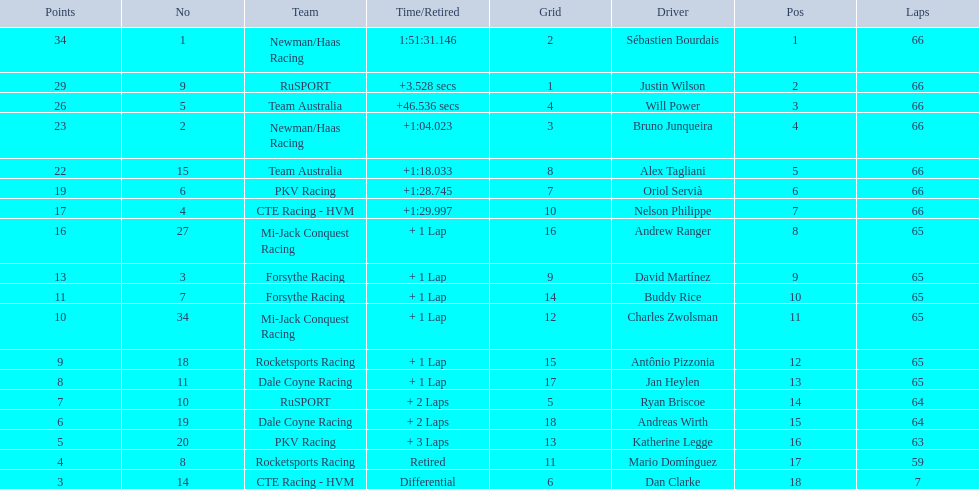Who are the drivers? Sébastien Bourdais, Justin Wilson, Will Power, Bruno Junqueira, Alex Tagliani, Oriol Servià, Nelson Philippe, Andrew Ranger, David Martínez, Buddy Rice, Charles Zwolsman, Antônio Pizzonia, Jan Heylen, Ryan Briscoe, Andreas Wirth, Katherine Legge, Mario Domínguez, Dan Clarke. What are their numbers? 1, 9, 5, 2, 15, 6, 4, 27, 3, 7, 34, 18, 11, 10, 19, 20, 8, 14. What are their positions? 1, 2, 3, 4, 5, 6, 7, 8, 9, 10, 11, 12, 13, 14, 15, 16, 17, 18. Parse the full table. {'header': ['Points', 'No', 'Team', 'Time/Retired', 'Grid', 'Driver', 'Pos', 'Laps'], 'rows': [['34', '1', 'Newman/Haas Racing', '1:51:31.146', '2', 'Sébastien Bourdais', '1', '66'], ['29', '9', 'RuSPORT', '+3.528 secs', '1', 'Justin Wilson', '2', '66'], ['26', '5', 'Team Australia', '+46.536 secs', '4', 'Will Power', '3', '66'], ['23', '2', 'Newman/Haas Racing', '+1:04.023', '3', 'Bruno Junqueira', '4', '66'], ['22', '15', 'Team Australia', '+1:18.033', '8', 'Alex Tagliani', '5', '66'], ['19', '6', 'PKV Racing', '+1:28.745', '7', 'Oriol Servià', '6', '66'], ['17', '4', 'CTE Racing - HVM', '+1:29.997', '10', 'Nelson Philippe', '7', '66'], ['16', '27', 'Mi-Jack Conquest Racing', '+ 1 Lap', '16', 'Andrew Ranger', '8', '65'], ['13', '3', 'Forsythe Racing', '+ 1 Lap', '9', 'David Martínez', '9', '65'], ['11', '7', 'Forsythe Racing', '+ 1 Lap', '14', 'Buddy Rice', '10', '65'], ['10', '34', 'Mi-Jack Conquest Racing', '+ 1 Lap', '12', 'Charles Zwolsman', '11', '65'], ['9', '18', 'Rocketsports Racing', '+ 1 Lap', '15', 'Antônio Pizzonia', '12', '65'], ['8', '11', 'Dale Coyne Racing', '+ 1 Lap', '17', 'Jan Heylen', '13', '65'], ['7', '10', 'RuSPORT', '+ 2 Laps', '5', 'Ryan Briscoe', '14', '64'], ['6', '19', 'Dale Coyne Racing', '+ 2 Laps', '18', 'Andreas Wirth', '15', '64'], ['5', '20', 'PKV Racing', '+ 3 Laps', '13', 'Katherine Legge', '16', '63'], ['4', '8', 'Rocketsports Racing', 'Retired', '11', 'Mario Domínguez', '17', '59'], ['3', '14', 'CTE Racing - HVM', 'Differential', '6', 'Dan Clarke', '18', '7']]} Which driver has the same number and position? Sébastien Bourdais. 